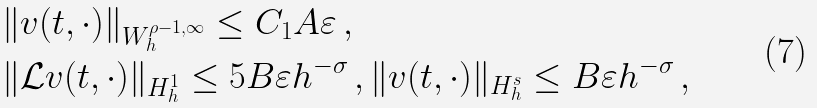<formula> <loc_0><loc_0><loc_500><loc_500>& \| v ( t , \cdot ) \| _ { W ^ { \rho - 1 , \infty } _ { h } } \leq C _ { 1 } A \varepsilon \, , \\ & \| \mathcal { L } v ( t , \cdot ) \| _ { H ^ { 1 } _ { h } } \leq 5 B \varepsilon h ^ { - \sigma } \, , \| v ( t , \cdot ) \| _ { H ^ { s } _ { h } } \leq B \varepsilon h ^ { - \sigma } \, ,</formula> 